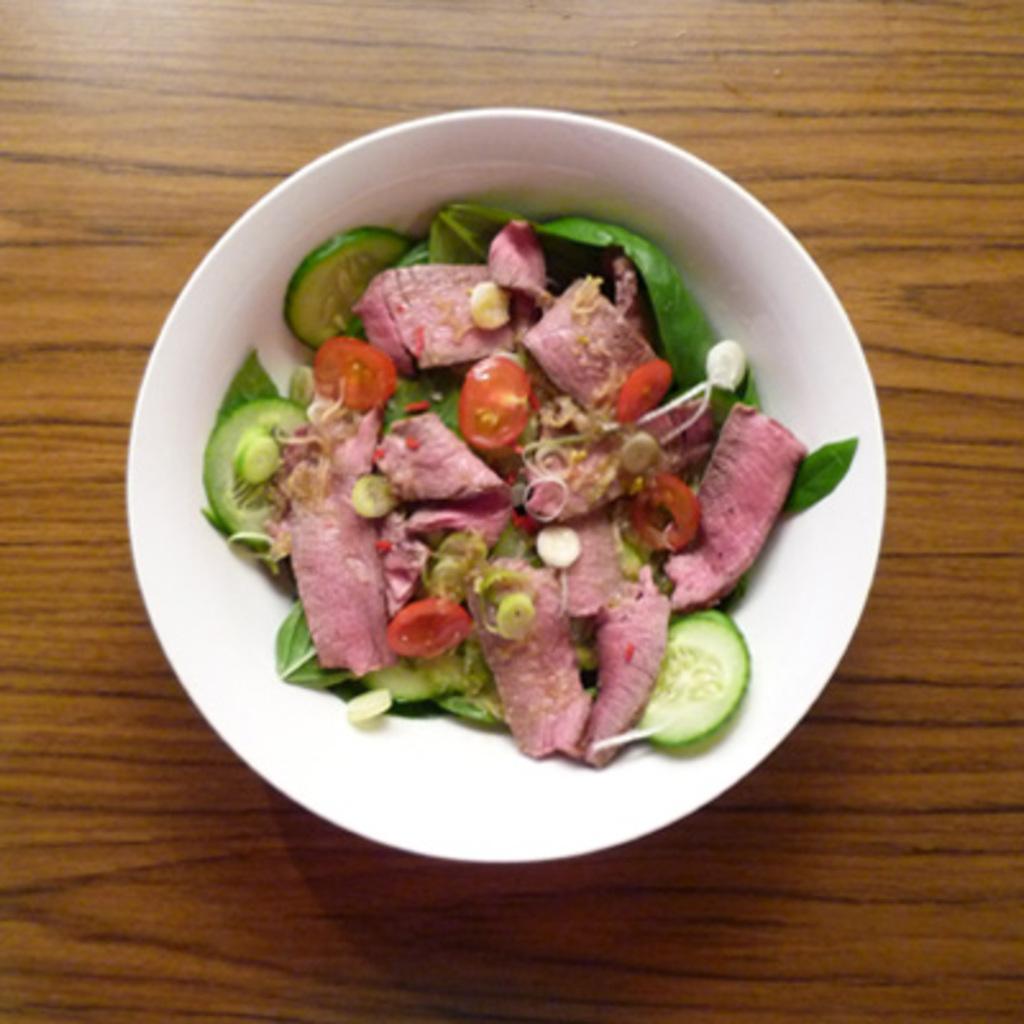Could you give a brief overview of what you see in this image? Here we can see bowl with food on the wooden surface. 